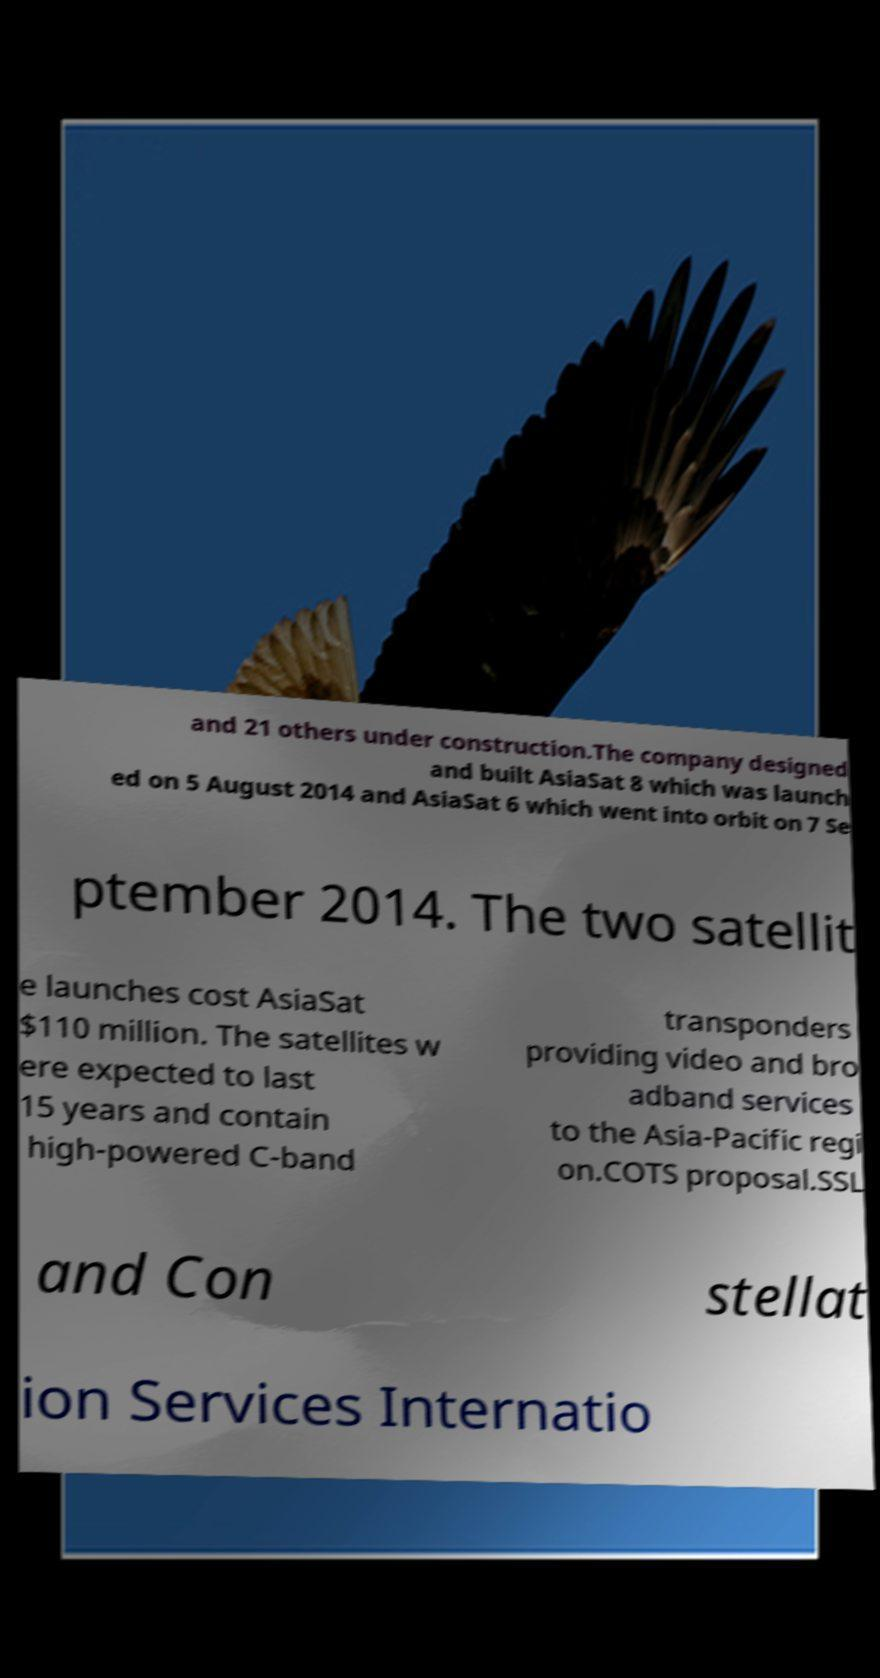For documentation purposes, I need the text within this image transcribed. Could you provide that? and 21 others under construction.The company designed and built AsiaSat 8 which was launch ed on 5 August 2014 and AsiaSat 6 which went into orbit on 7 Se ptember 2014. The two satellit e launches cost AsiaSat $110 million. The satellites w ere expected to last 15 years and contain high-powered C-band transponders providing video and bro adband services to the Asia-Pacific regi on.COTS proposal.SSL and Con stellat ion Services Internatio 